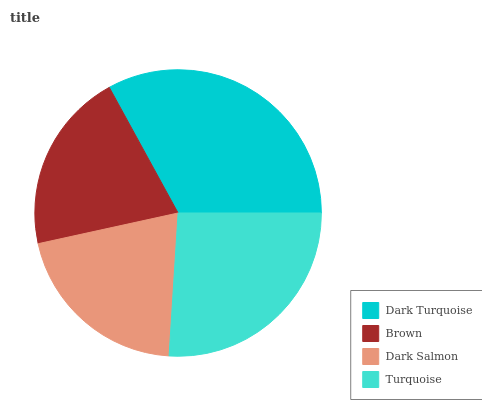Is Brown the minimum?
Answer yes or no. Yes. Is Dark Turquoise the maximum?
Answer yes or no. Yes. Is Dark Salmon the minimum?
Answer yes or no. No. Is Dark Salmon the maximum?
Answer yes or no. No. Is Dark Salmon greater than Brown?
Answer yes or no. Yes. Is Brown less than Dark Salmon?
Answer yes or no. Yes. Is Brown greater than Dark Salmon?
Answer yes or no. No. Is Dark Salmon less than Brown?
Answer yes or no. No. Is Turquoise the high median?
Answer yes or no. Yes. Is Dark Salmon the low median?
Answer yes or no. Yes. Is Dark Salmon the high median?
Answer yes or no. No. Is Turquoise the low median?
Answer yes or no. No. 